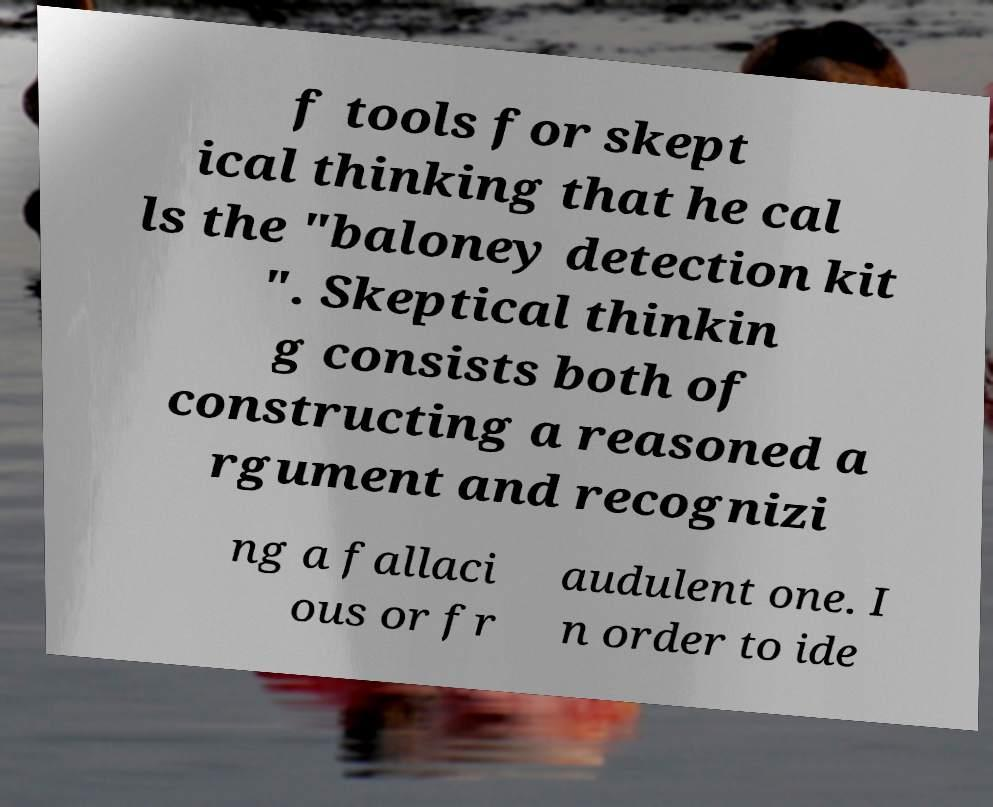For documentation purposes, I need the text within this image transcribed. Could you provide that? f tools for skept ical thinking that he cal ls the "baloney detection kit ". Skeptical thinkin g consists both of constructing a reasoned a rgument and recognizi ng a fallaci ous or fr audulent one. I n order to ide 